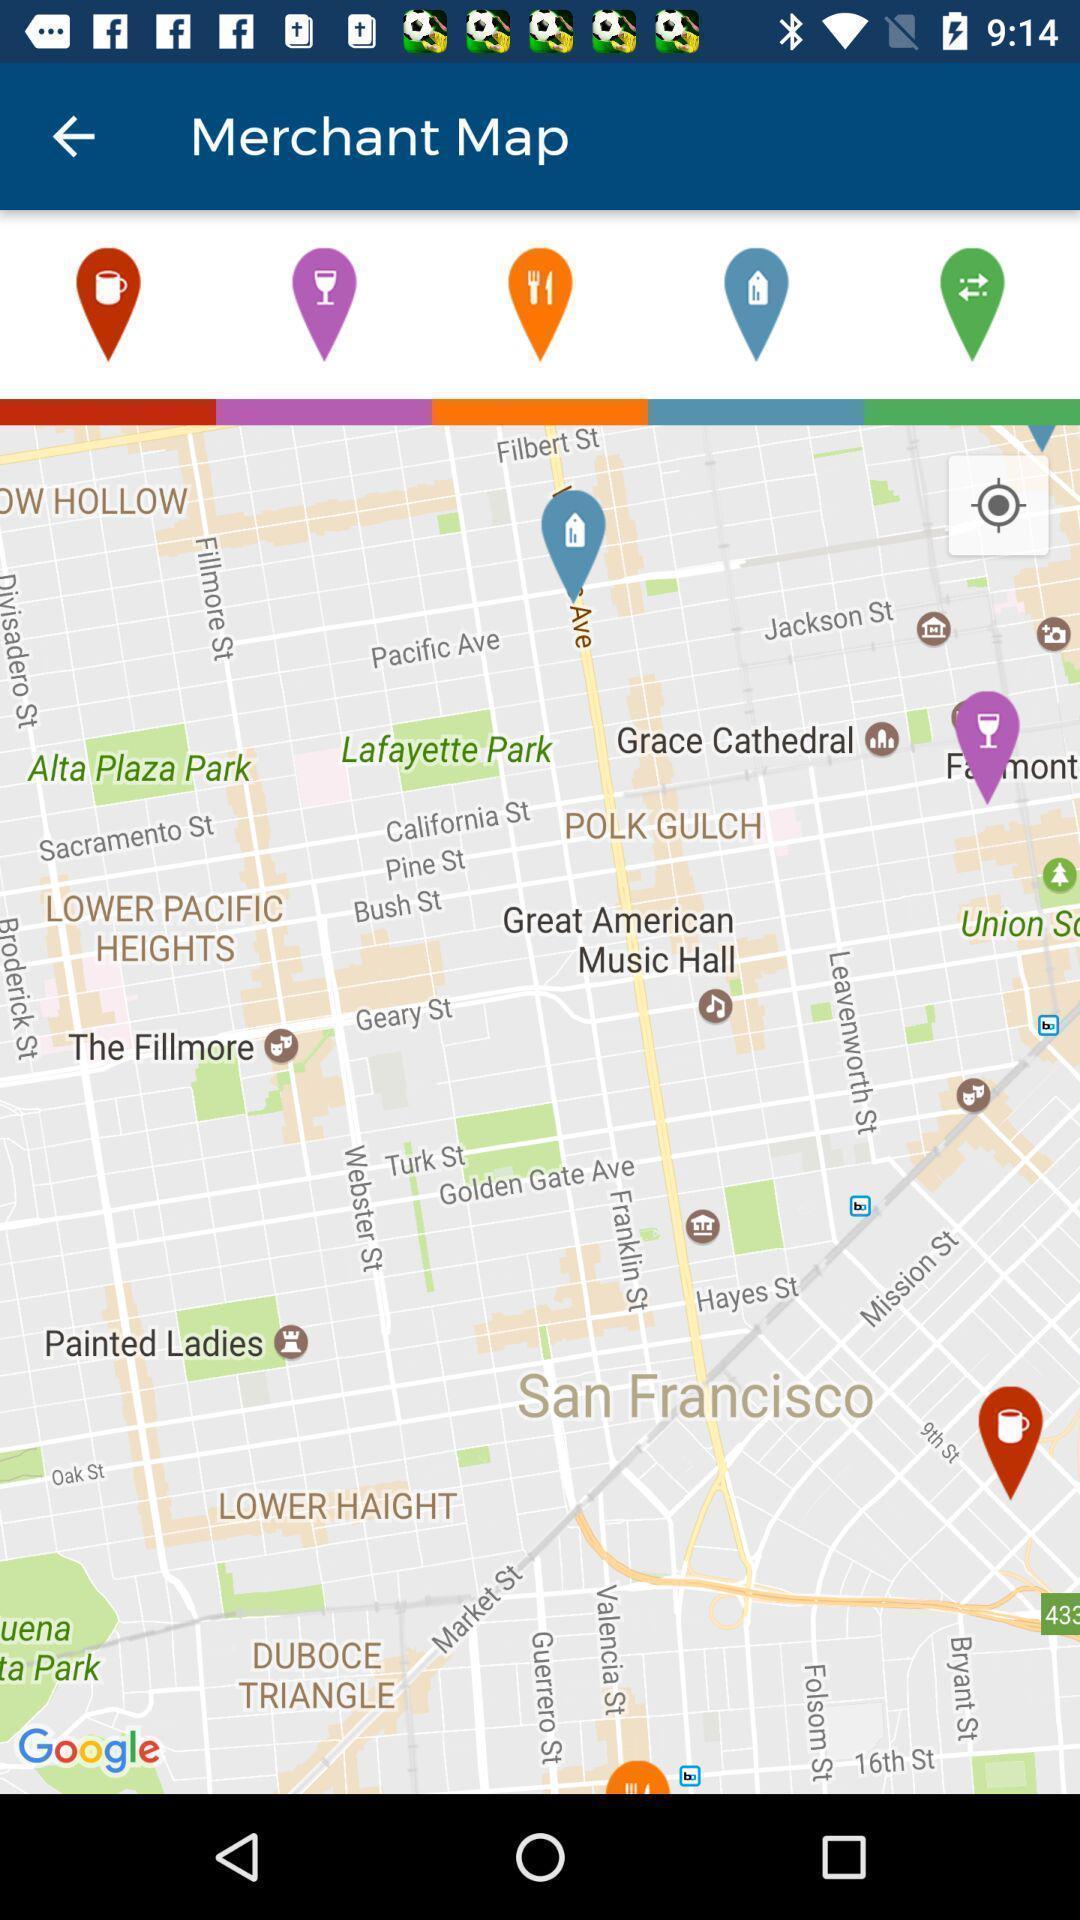Please provide a description for this image. Screen page displaying map with different options. 